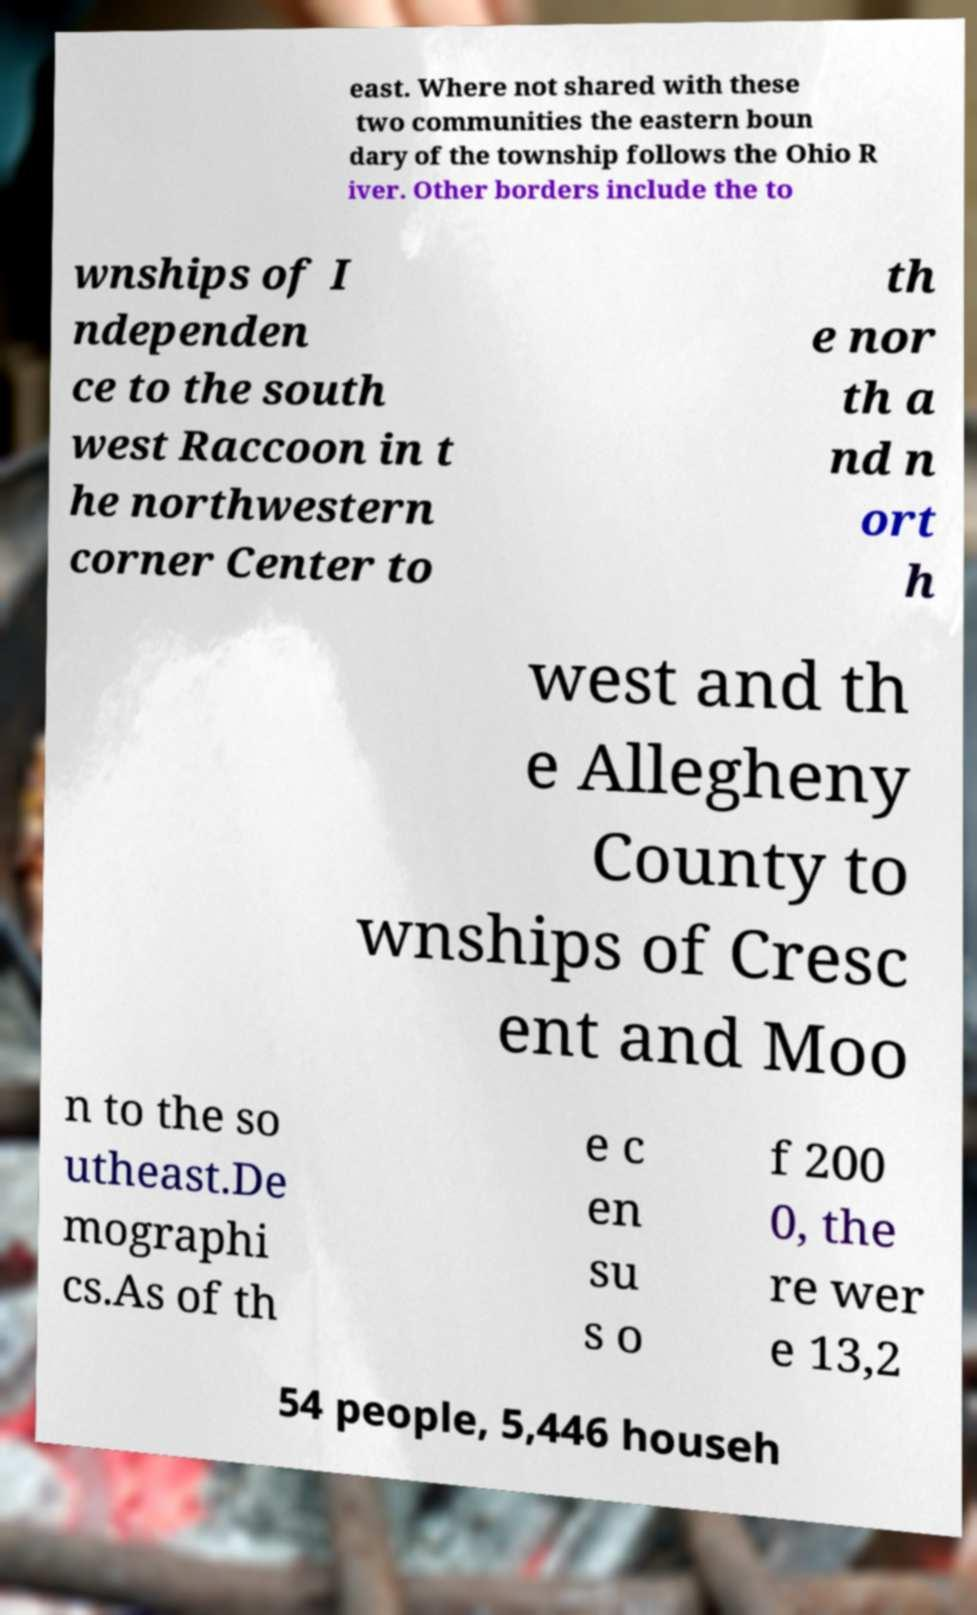Can you accurately transcribe the text from the provided image for me? east. Where not shared with these two communities the eastern boun dary of the township follows the Ohio R iver. Other borders include the to wnships of I ndependen ce to the south west Raccoon in t he northwestern corner Center to th e nor th a nd n ort h west and th e Allegheny County to wnships of Cresc ent and Moo n to the so utheast.De mographi cs.As of th e c en su s o f 200 0, the re wer e 13,2 54 people, 5,446 househ 